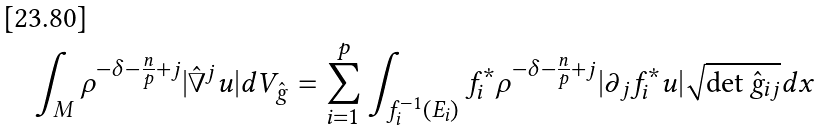Convert formula to latex. <formula><loc_0><loc_0><loc_500><loc_500>\int _ { M } \rho ^ { - \delta - \frac { n } { p } + j } | \hat { \nabla } ^ { j } u | d V _ { \hat { g } } = \sum _ { i = 1 } ^ { p } \int _ { f _ { i } ^ { - 1 } ( E _ { i } ) } f _ { i } ^ { \ast } \rho ^ { - \delta - \frac { n } { p } + j } | \partial _ { j } f _ { i } ^ { \ast } u | \sqrt { \det \hat { g } _ { i j } } d x</formula> 